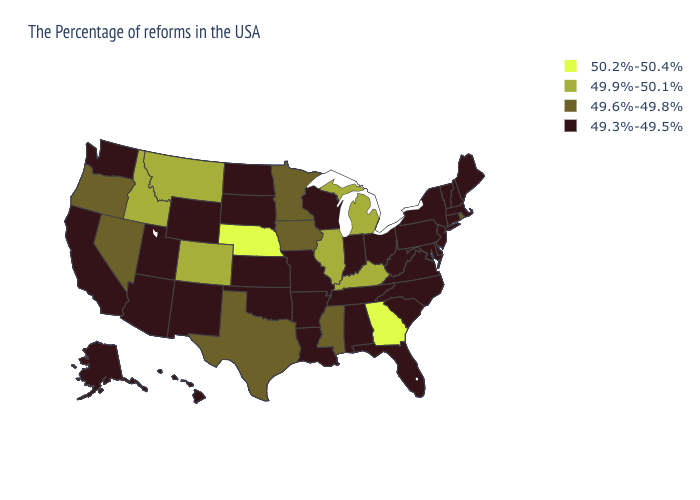Among the states that border Utah , which have the highest value?
Quick response, please. Colorado, Idaho. Does North Dakota have the lowest value in the MidWest?
Short answer required. Yes. Does the first symbol in the legend represent the smallest category?
Write a very short answer. No. Among the states that border Washington , which have the highest value?
Write a very short answer. Idaho. What is the lowest value in the USA?
Give a very brief answer. 49.3%-49.5%. Name the states that have a value in the range 49.6%-49.8%?
Answer briefly. Rhode Island, Mississippi, Minnesota, Iowa, Texas, Nevada, Oregon. What is the value of Arkansas?
Write a very short answer. 49.3%-49.5%. What is the value of Kentucky?
Concise answer only. 49.9%-50.1%. Among the states that border Oklahoma , which have the highest value?
Write a very short answer. Colorado. Does the first symbol in the legend represent the smallest category?
Be succinct. No. What is the value of Oklahoma?
Concise answer only. 49.3%-49.5%. Does Texas have the lowest value in the USA?
Answer briefly. No. Does Missouri have the same value as South Carolina?
Answer briefly. Yes. Name the states that have a value in the range 49.9%-50.1%?
Short answer required. Michigan, Kentucky, Illinois, Colorado, Montana, Idaho. Does Georgia have the highest value in the USA?
Concise answer only. Yes. 